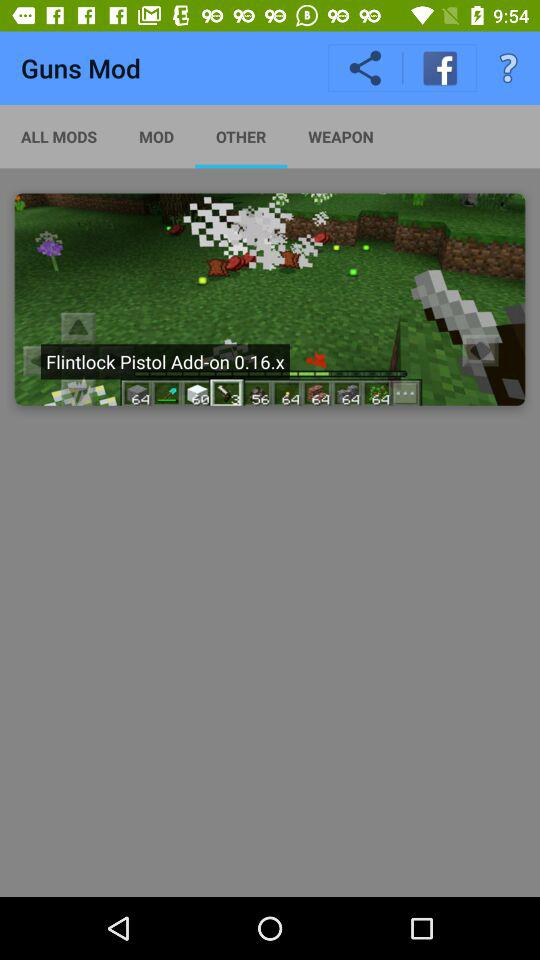What is the application name? The application name is "Guns Mod". 